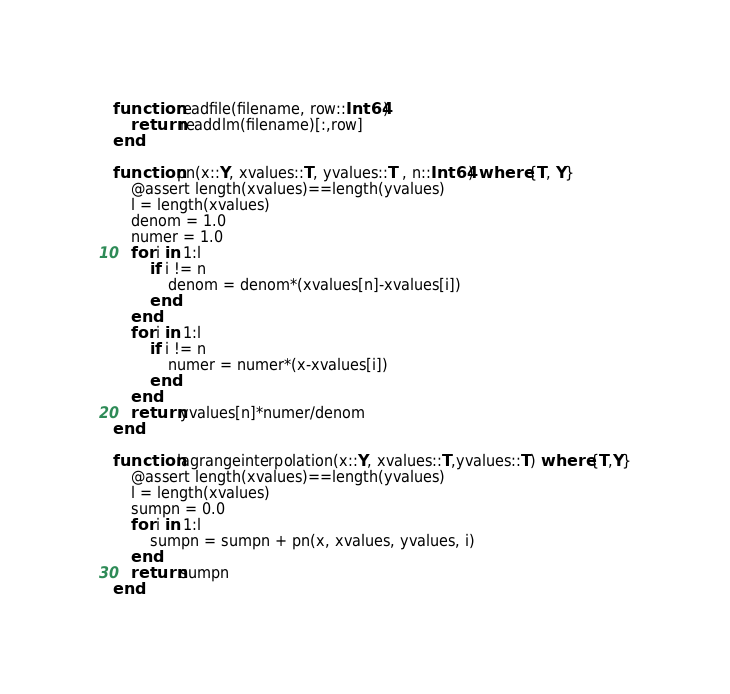<code> <loc_0><loc_0><loc_500><loc_500><_Julia_>function readfile(filename, row::Int64)
    return readdlm(filename)[:,row]
end

function pn(x::Y, xvalues::T, yvalues::T , n::Int64) where {T, Y}
    @assert length(xvalues)==length(yvalues)
    l = length(xvalues)
    denom = 1.0
    numer = 1.0
    for i in 1:l
        if i != n
            denom = denom*(xvalues[n]-xvalues[i])
        end
    end
    for i in 1:l
        if i != n
            numer = numer*(x-xvalues[i])
        end
    end
    return yvalues[n]*numer/denom
end

function lagrangeinterpolation(x::Y, xvalues::T,yvalues::T) where {T,Y}
    @assert length(xvalues)==length(yvalues)
    l = length(xvalues)
    sumpn = 0.0
    for i in 1:l
        sumpn = sumpn + pn(x, xvalues, yvalues, i)
    end
    return sumpn
end

</code> 